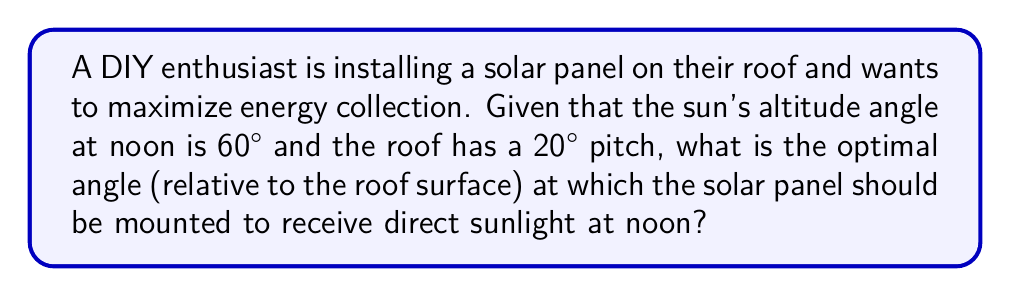What is the answer to this math problem? Let's approach this step-by-step:

1) The optimal angle for a solar panel is when it's perpendicular to the sun's rays. This means we want the panel to form a 90° angle with the incoming sunlight.

2) Let's define our angles:
   - Sun's altitude angle: $\alpha = 60°$
   - Roof pitch: $\beta = 20°$
   - Solar panel angle relative to roof: $\theta$ (this is what we're solving for)

3) We can visualize this as follows:

[asy]
import geometry;

size(200);
defaultpen(fontsize(10pt));

pair A = (0,0), B = (100,0), C = (100,36.4), D = (100,173.2);
draw(A--B--C--cycle);
draw(B--D);

label("Roof", (50,-10));
label("Solar Panel", (120,100), E);
label("Sun's rays", (120,173.2), E);

markangle("$\beta$", A, B, C, radius=20);
markangle("$\theta$", B, C, D, radius=30);
markangle("$\alpha$", A, B, D, radius=40);
markangle("90°", C, D, B, radius=15);
[/asy]

4) From the diagram, we can see that:
   $$90° = \alpha + \beta + \theta$$

5) Substituting the known values:
   $$90° = 60° + 20° + \theta$$

6) Solving for $\theta$:
   $$\theta = 90° - 60° - 20° = 10°$$

Therefore, the solar panel should be mounted at a 10° angle relative to the roof surface.
Answer: $10°$ 